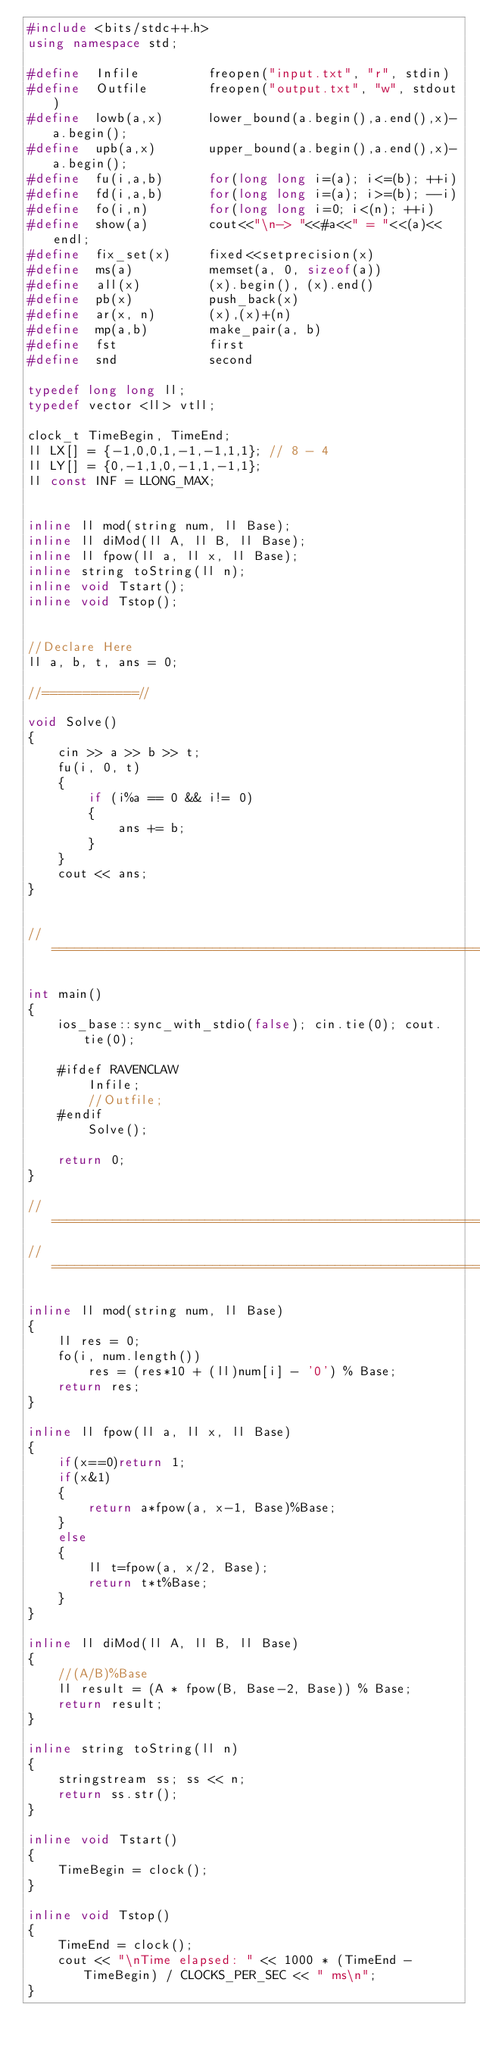Convert code to text. <code><loc_0><loc_0><loc_500><loc_500><_C++_>#include <bits/stdc++.h>
using namespace std;

#define  Infile			freopen("input.txt", "r", stdin)
#define  Outfile		freopen("output.txt", "w", stdout)
#define  lowb(a,x) 		lower_bound(a.begin(),a.end(),x)-a.begin();
#define  upb(a,x) 		upper_bound(a.begin(),a.end(),x)-a.begin();
#define  fu(i,a,b)		for(long long i=(a); i<=(b); ++i)
#define  fd(i,a,b)		for(long long i=(a); i>=(b); --i)
#define  fo(i,n)		for(long long i=0; i<(n); ++i)
#define  show(a) 		cout<<"\n-> "<<#a<<" = "<<(a)<<endl;
#define  fix_set(x)		fixed<<setprecision(x)
#define  ms(a)			memset(a, 0, sizeof(a))
#define  all(x)			(x).begin(), (x).end()
#define  pb(x)			push_back(x)
#define  ar(x, n)		(x),(x)+(n)
#define  mp(a,b)		make_pair(a, b)
#define	 fst			first
#define	 snd			second

typedef long long ll;
typedef vector <ll> vtll;

clock_t TimeBegin, TimeEnd;
ll LX[] = {-1,0,0,1,-1,-1,1,1}; // 8 - 4
ll LY[] = {0,-1,1,0,-1,1,-1,1}; 
ll const INF = LLONG_MAX;


inline ll mod(string num, ll Base);
inline ll diMod(ll A, ll B, ll Base);
inline ll fpow(ll a, ll x, ll Base);
inline string toString(ll n);
inline void Tstart();
inline void Tstop();


//Declare Here
ll a, b, t, ans = 0;

//============//

void Solve()
{
	cin >> a >> b >> t;
	fu(i, 0, t)
	{
		if (i%a == 0 && i!= 0)
		{
			ans += b;
		}
	}
	cout << ans;
}


//=============================================================================//

int main()
{
	ios_base::sync_with_stdio(false); cin.tie(0); cout.tie(0);

	#ifdef RAVENCLAW
		Infile;
		//Outfile;
	#endif
		Solve();

	return 0;
}

//=============================================================================//
//=============================================================================//

inline ll mod(string num, ll Base) 
{ 
    ll res = 0; 
    fo(i, num.length()) 
        res = (res*10 + (ll)num[i] - '0') % Base;
    return res; 
} 

inline ll fpow(ll a, ll x, ll Base)
{
	if(x==0)return 1;	
	if(x&1) 
	{
		return a*fpow(a, x-1, Base)%Base;
	} 
	else
	{
		ll t=fpow(a, x/2, Base);
		return t*t%Base;
	}
}

inline ll diMod(ll A, ll B, ll Base)
{
	//(A/B)%Base
	ll result = (A * fpow(B, Base-2, Base)) % Base; 
	return result;
}

inline string toString(ll n) 
{
	stringstream ss; ss << n;
	return ss.str();
}	

inline void Tstart()
{
	TimeBegin = clock();
}

inline void Tstop()
{
	TimeEnd = clock();
	cout << "\nTime elapsed: " << 1000 * (TimeEnd - TimeBegin) / CLOCKS_PER_SEC << " ms\n";
}</code> 